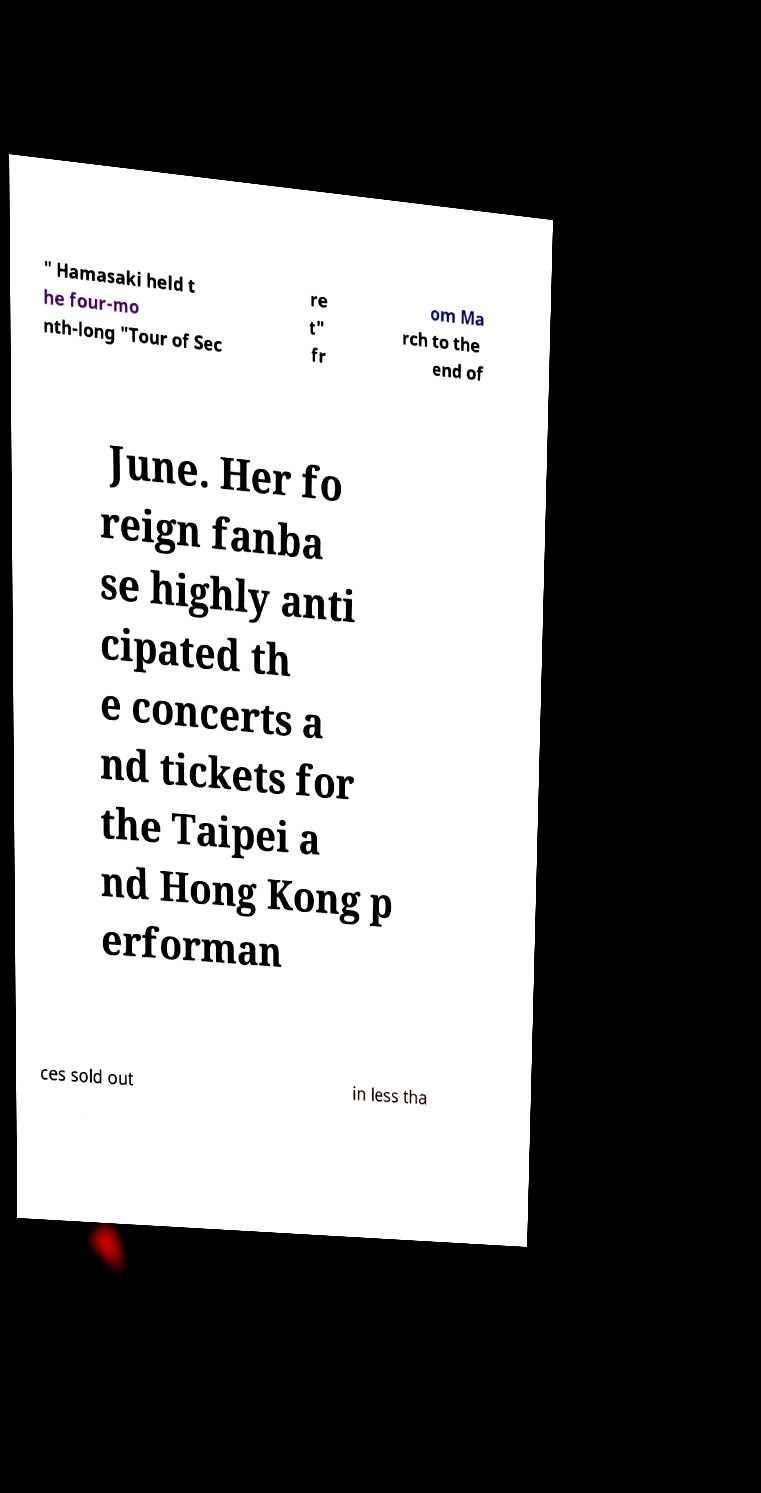For documentation purposes, I need the text within this image transcribed. Could you provide that? " Hamasaki held t he four-mo nth-long "Tour of Sec re t" fr om Ma rch to the end of June. Her fo reign fanba se highly anti cipated th e concerts a nd tickets for the Taipei a nd Hong Kong p erforman ces sold out in less tha 